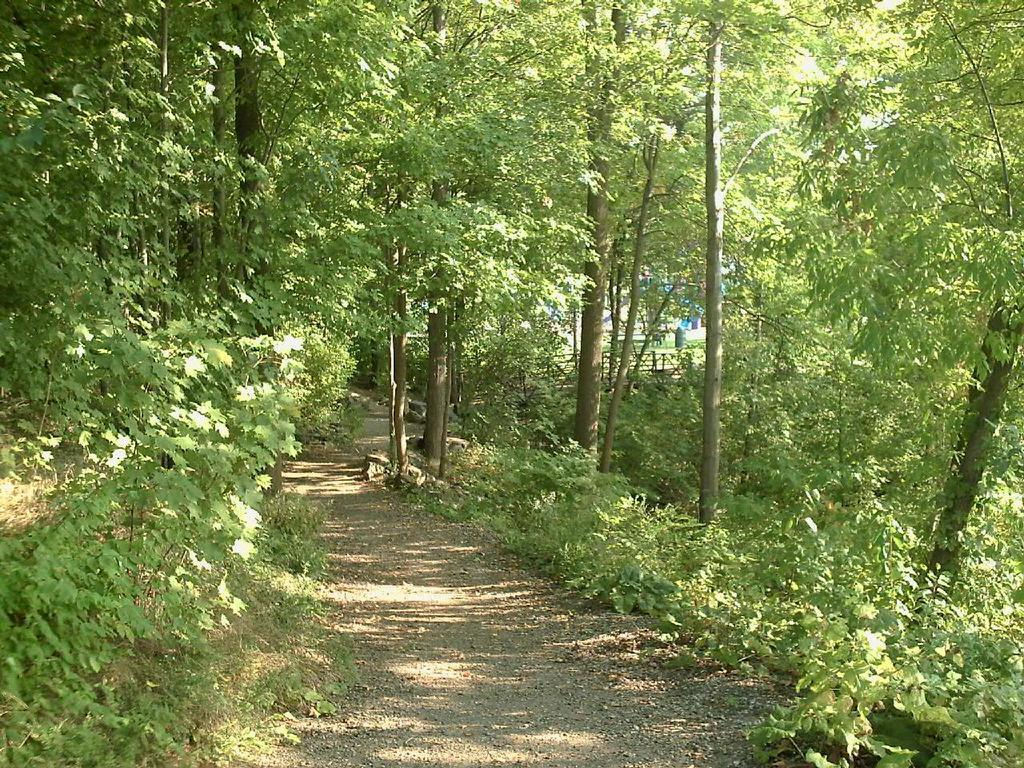What type of vegetation can be seen in the image? There are green color trees in the image. What else is present in the image besides the trees? There is fencing visible in the image. What is the price of the plant in the image? There is no plant present in the image, so it is not possible to determine its price. 